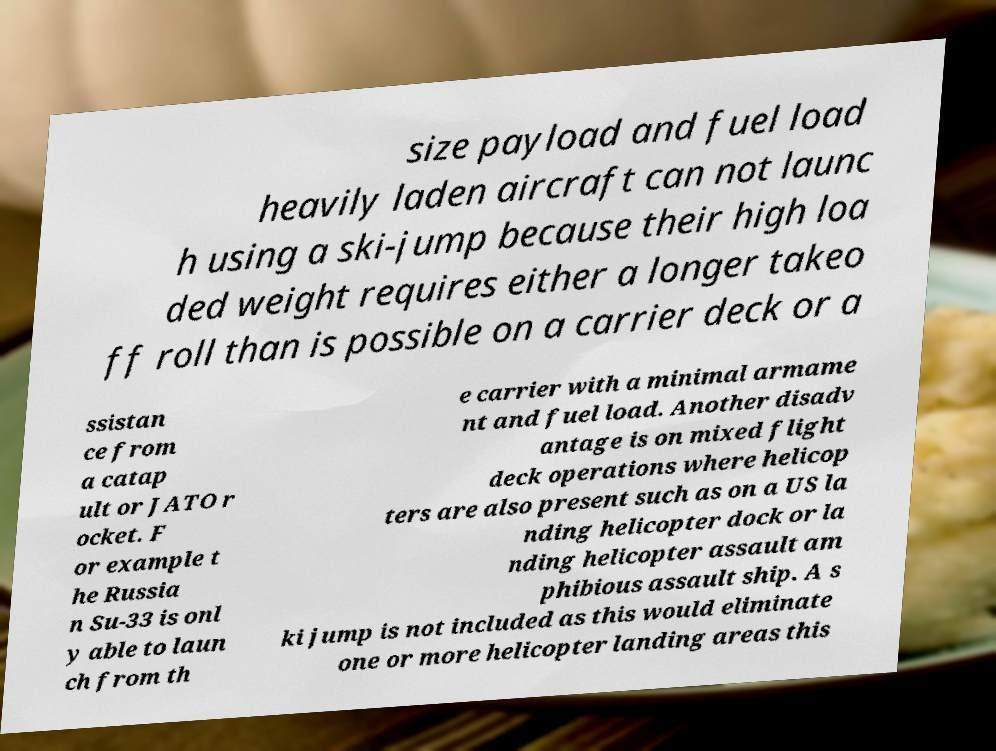Please identify and transcribe the text found in this image. size payload and fuel load heavily laden aircraft can not launc h using a ski-jump because their high loa ded weight requires either a longer takeo ff roll than is possible on a carrier deck or a ssistan ce from a catap ult or JATO r ocket. F or example t he Russia n Su-33 is onl y able to laun ch from th e carrier with a minimal armame nt and fuel load. Another disadv antage is on mixed flight deck operations where helicop ters are also present such as on a US la nding helicopter dock or la nding helicopter assault am phibious assault ship. A s ki jump is not included as this would eliminate one or more helicopter landing areas this 